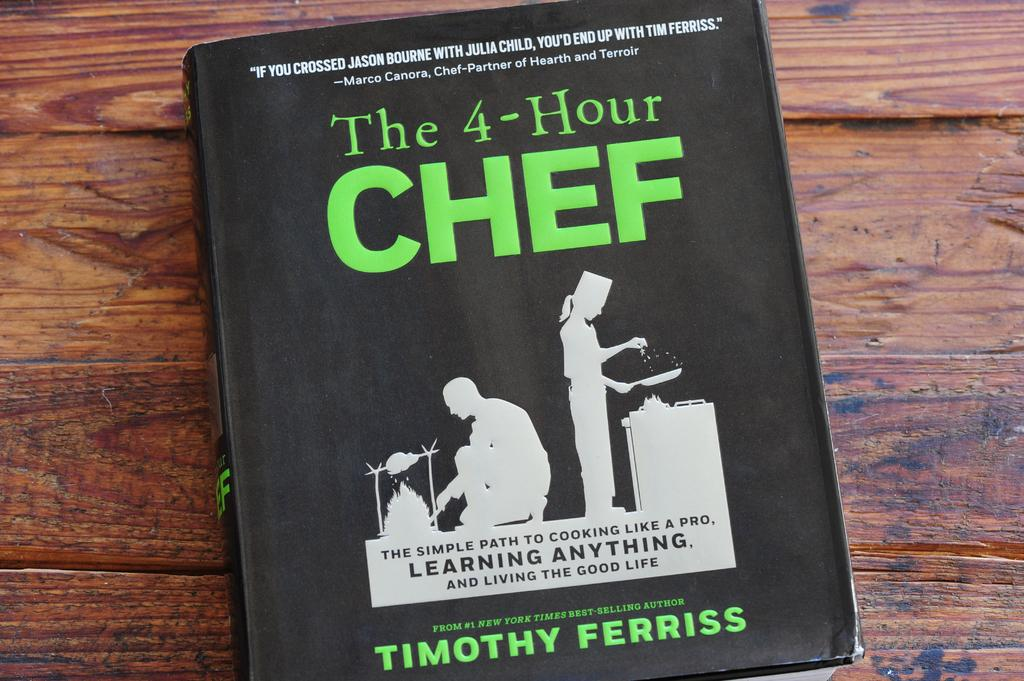<image>
Present a compact description of the photo's key features. A copy of the book the four hour chef by timothy ferriss. 